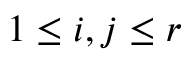<formula> <loc_0><loc_0><loc_500><loc_500>1 \leq i , j \leq r</formula> 